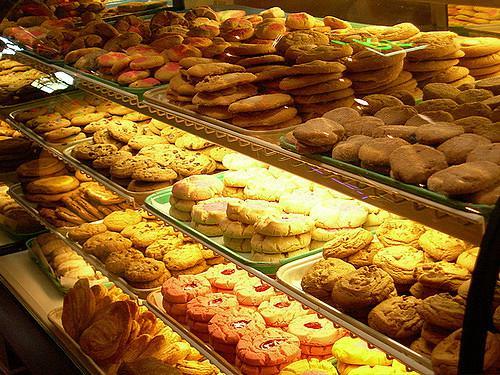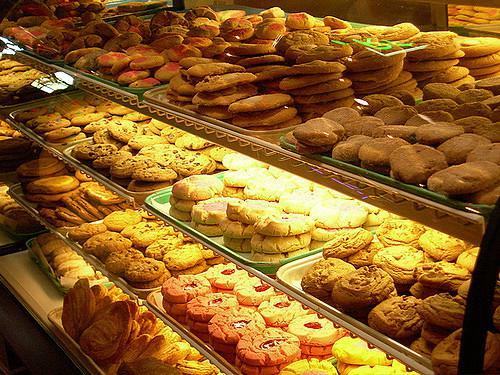The first image is the image on the left, the second image is the image on the right. For the images shown, is this caption "One of the images shows the flooring in front of a glass fronted display case." true? Answer yes or no. No. 